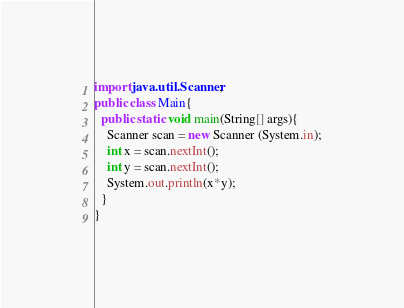Convert code to text. <code><loc_0><loc_0><loc_500><loc_500><_Java_>import java.util.Scanner;
public class Main{
  public static void main(String[] args){
    Scanner scan = new Scanner (System.in);
    int x = scan.nextInt();
    int y = scan.nextInt();
    System.out.println(x*y);
  }
}</code> 